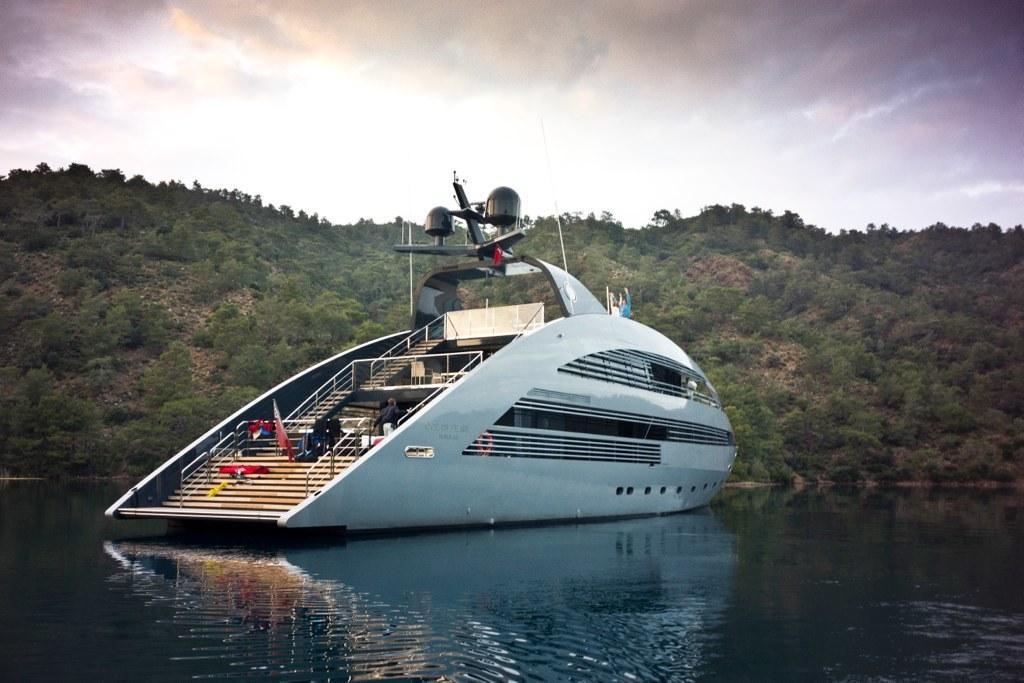Can you describe this image briefly? In this picture we can see a ship on the water and we can find a man in the ship, in the background we can see few trees and clouds. 